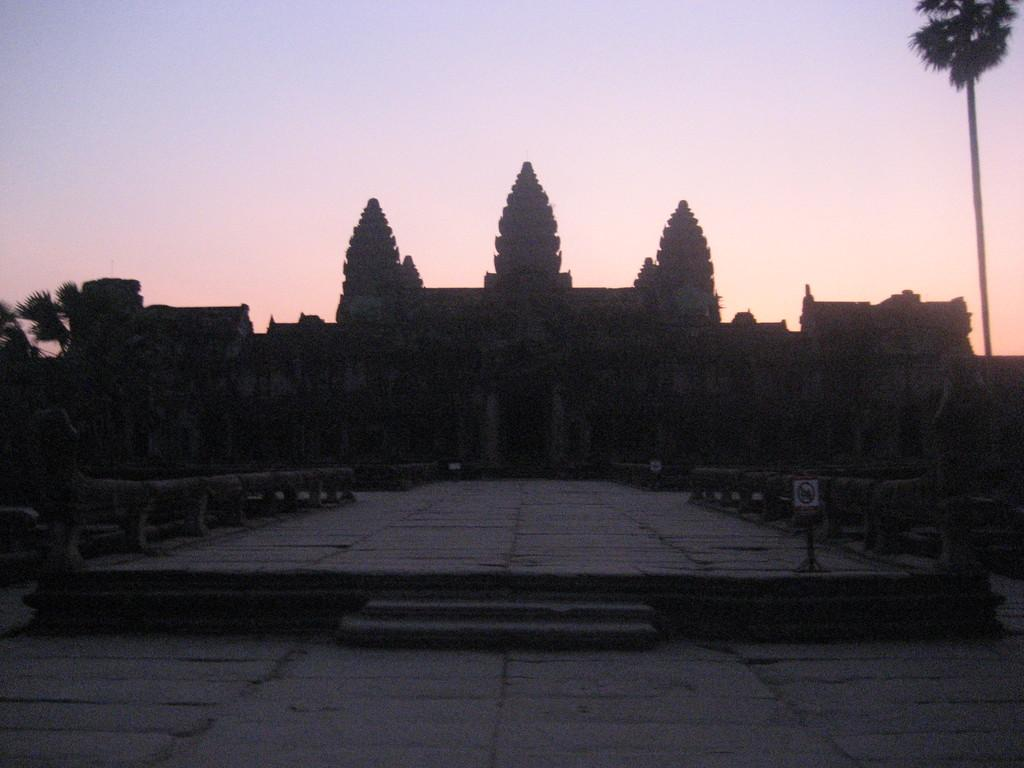What type of structures can be seen in the image? There are buildings in the image. What other natural elements are present in the image? There are trees in the image. What can be seen in the background of the image? The sky is visible in the background of the image. What colors are present in the sky? The sky is blue and white in color. What architectural feature is present in the foreground of the image? There are stairs in front of the image. How many grapes are hanging from the trees in the image? There are no grapes visible in the image; the trees are not identified as fruit-bearing trees. What type of wing is present in the image? There is no wing present in the image; the focus is on buildings, trees, and the sky. 